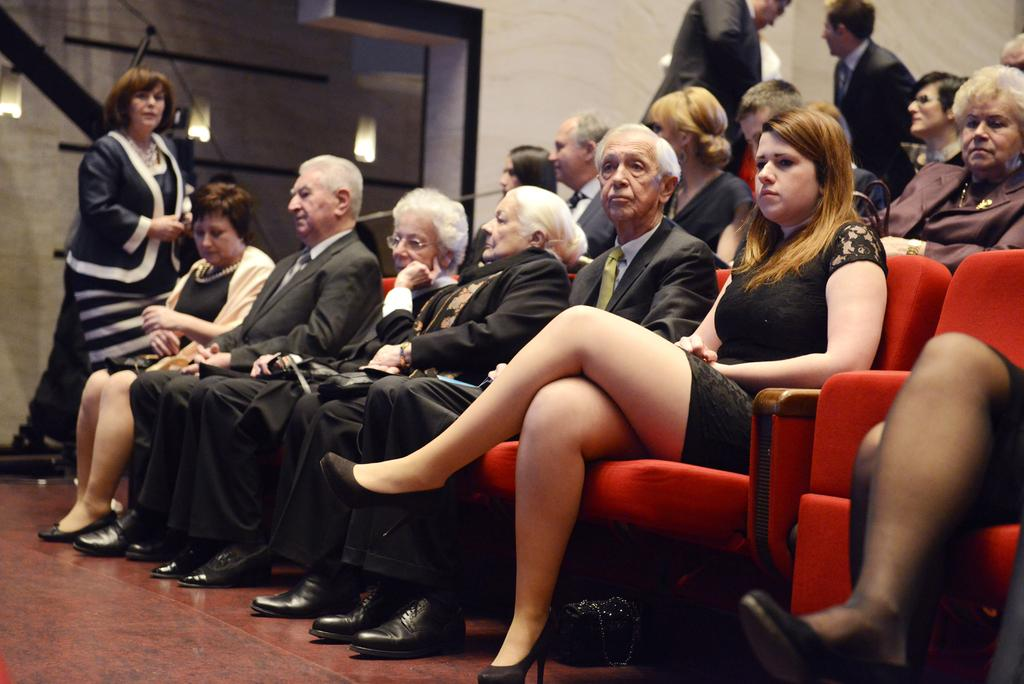What are the people in the image doing? The people in the image are sitting on chairs. How many people are standing in the image? There are three persons standing in the image. What can be seen in the background of the image? There is a wall and lights visible in the background of the image. What type of joke is being told by the person standing in the image? There is no indication in the image that a joke is being told, and therefore no such activity can be observed. 